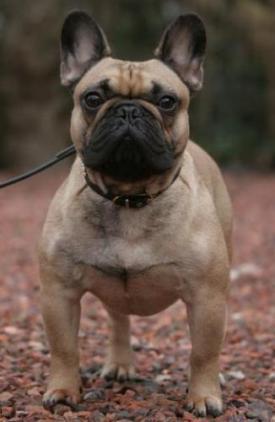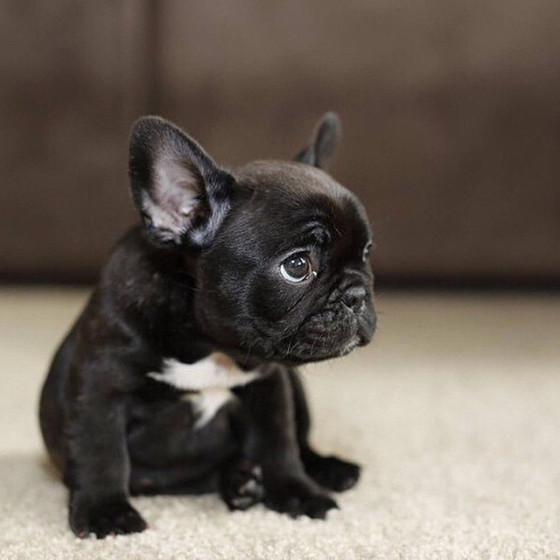The first image is the image on the left, the second image is the image on the right. For the images shown, is this caption "One of the images features a dog that is wearing a collar." true? Answer yes or no. Yes. The first image is the image on the left, the second image is the image on the right. For the images displayed, is the sentence "One image features two french bulldogs sitting upright, and the other image features a single dog." factually correct? Answer yes or no. No. 